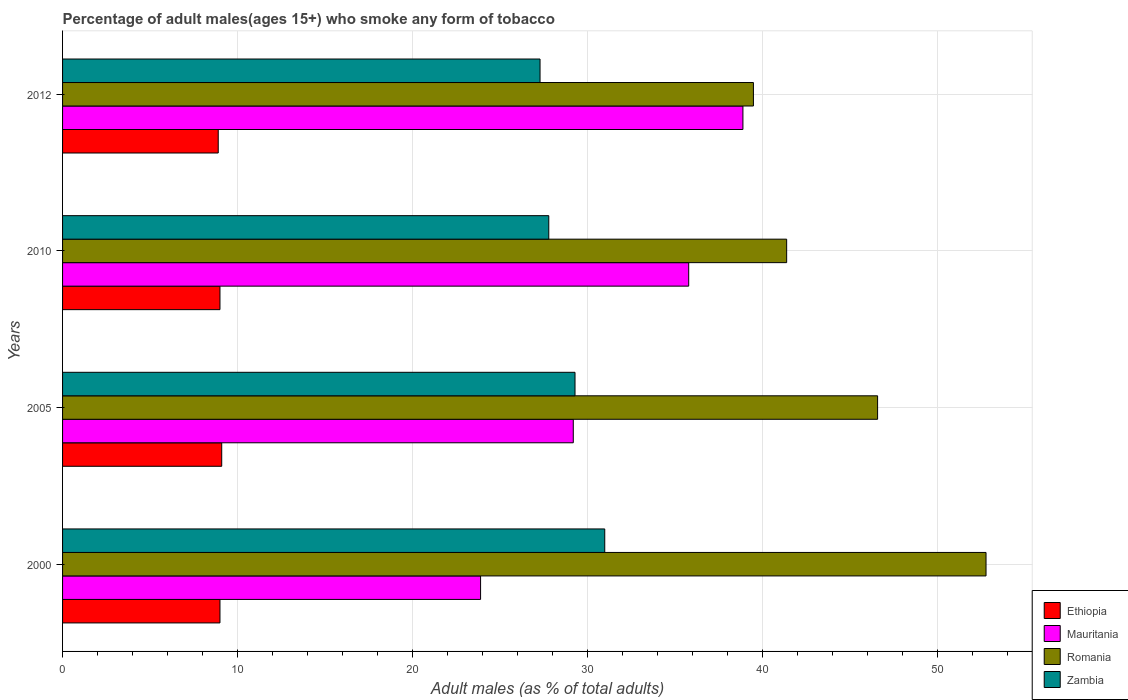Are the number of bars per tick equal to the number of legend labels?
Your answer should be compact. Yes. Are the number of bars on each tick of the Y-axis equal?
Your response must be concise. Yes. How many bars are there on the 2nd tick from the bottom?
Keep it short and to the point. 4. What is the label of the 4th group of bars from the top?
Offer a terse response. 2000. In how many cases, is the number of bars for a given year not equal to the number of legend labels?
Offer a terse response. 0. Across all years, what is the maximum percentage of adult males who smoke in Romania?
Keep it short and to the point. 52.8. Across all years, what is the minimum percentage of adult males who smoke in Romania?
Offer a very short reply. 39.5. In which year was the percentage of adult males who smoke in Romania maximum?
Offer a very short reply. 2000. What is the total percentage of adult males who smoke in Romania in the graph?
Offer a terse response. 180.3. What is the difference between the percentage of adult males who smoke in Ethiopia in 2000 and that in 2012?
Offer a very short reply. 0.1. What is the difference between the percentage of adult males who smoke in Zambia in 2000 and the percentage of adult males who smoke in Ethiopia in 2012?
Offer a terse response. 22.1. What is the average percentage of adult males who smoke in Mauritania per year?
Keep it short and to the point. 31.95. What is the ratio of the percentage of adult males who smoke in Zambia in 2000 to that in 2012?
Your response must be concise. 1.14. Is the percentage of adult males who smoke in Romania in 2005 less than that in 2012?
Your answer should be compact. No. Is the difference between the percentage of adult males who smoke in Zambia in 2000 and 2010 greater than the difference between the percentage of adult males who smoke in Ethiopia in 2000 and 2010?
Offer a very short reply. Yes. What is the difference between the highest and the second highest percentage of adult males who smoke in Mauritania?
Offer a terse response. 3.1. Is it the case that in every year, the sum of the percentage of adult males who smoke in Romania and percentage of adult males who smoke in Mauritania is greater than the sum of percentage of adult males who smoke in Ethiopia and percentage of adult males who smoke in Zambia?
Keep it short and to the point. Yes. What does the 1st bar from the top in 2010 represents?
Give a very brief answer. Zambia. What does the 1st bar from the bottom in 2012 represents?
Offer a very short reply. Ethiopia. How many bars are there?
Offer a very short reply. 16. Are all the bars in the graph horizontal?
Give a very brief answer. Yes. How many years are there in the graph?
Provide a succinct answer. 4. Are the values on the major ticks of X-axis written in scientific E-notation?
Your response must be concise. No. Does the graph contain any zero values?
Provide a succinct answer. No. Where does the legend appear in the graph?
Your answer should be very brief. Bottom right. How are the legend labels stacked?
Ensure brevity in your answer.  Vertical. What is the title of the graph?
Your answer should be compact. Percentage of adult males(ages 15+) who smoke any form of tobacco. What is the label or title of the X-axis?
Your answer should be very brief. Adult males (as % of total adults). What is the label or title of the Y-axis?
Keep it short and to the point. Years. What is the Adult males (as % of total adults) of Mauritania in 2000?
Give a very brief answer. 23.9. What is the Adult males (as % of total adults) of Romania in 2000?
Offer a terse response. 52.8. What is the Adult males (as % of total adults) in Zambia in 2000?
Give a very brief answer. 31. What is the Adult males (as % of total adults) of Mauritania in 2005?
Keep it short and to the point. 29.2. What is the Adult males (as % of total adults) in Romania in 2005?
Give a very brief answer. 46.6. What is the Adult males (as % of total adults) in Zambia in 2005?
Your response must be concise. 29.3. What is the Adult males (as % of total adults) of Mauritania in 2010?
Ensure brevity in your answer.  35.8. What is the Adult males (as % of total adults) of Romania in 2010?
Provide a succinct answer. 41.4. What is the Adult males (as % of total adults) in Zambia in 2010?
Offer a very short reply. 27.8. What is the Adult males (as % of total adults) in Mauritania in 2012?
Provide a succinct answer. 38.9. What is the Adult males (as % of total adults) of Romania in 2012?
Your response must be concise. 39.5. What is the Adult males (as % of total adults) of Zambia in 2012?
Keep it short and to the point. 27.3. Across all years, what is the maximum Adult males (as % of total adults) of Mauritania?
Provide a succinct answer. 38.9. Across all years, what is the maximum Adult males (as % of total adults) in Romania?
Your answer should be very brief. 52.8. Across all years, what is the minimum Adult males (as % of total adults) in Ethiopia?
Provide a succinct answer. 8.9. Across all years, what is the minimum Adult males (as % of total adults) in Mauritania?
Offer a very short reply. 23.9. Across all years, what is the minimum Adult males (as % of total adults) in Romania?
Your response must be concise. 39.5. Across all years, what is the minimum Adult males (as % of total adults) in Zambia?
Ensure brevity in your answer.  27.3. What is the total Adult males (as % of total adults) in Ethiopia in the graph?
Ensure brevity in your answer.  36. What is the total Adult males (as % of total adults) in Mauritania in the graph?
Provide a short and direct response. 127.8. What is the total Adult males (as % of total adults) of Romania in the graph?
Your answer should be very brief. 180.3. What is the total Adult males (as % of total adults) in Zambia in the graph?
Provide a succinct answer. 115.4. What is the difference between the Adult males (as % of total adults) in Mauritania in 2000 and that in 2005?
Ensure brevity in your answer.  -5.3. What is the difference between the Adult males (as % of total adults) in Zambia in 2000 and that in 2005?
Provide a short and direct response. 1.7. What is the difference between the Adult males (as % of total adults) of Zambia in 2000 and that in 2010?
Offer a terse response. 3.2. What is the difference between the Adult males (as % of total adults) in Ethiopia in 2000 and that in 2012?
Offer a very short reply. 0.1. What is the difference between the Adult males (as % of total adults) in Mauritania in 2000 and that in 2012?
Make the answer very short. -15. What is the difference between the Adult males (as % of total adults) in Mauritania in 2005 and that in 2010?
Offer a very short reply. -6.6. What is the difference between the Adult males (as % of total adults) in Zambia in 2005 and that in 2010?
Make the answer very short. 1.5. What is the difference between the Adult males (as % of total adults) of Ethiopia in 2005 and that in 2012?
Offer a terse response. 0.2. What is the difference between the Adult males (as % of total adults) of Zambia in 2005 and that in 2012?
Offer a very short reply. 2. What is the difference between the Adult males (as % of total adults) in Mauritania in 2010 and that in 2012?
Make the answer very short. -3.1. What is the difference between the Adult males (as % of total adults) of Ethiopia in 2000 and the Adult males (as % of total adults) of Mauritania in 2005?
Your response must be concise. -20.2. What is the difference between the Adult males (as % of total adults) in Ethiopia in 2000 and the Adult males (as % of total adults) in Romania in 2005?
Provide a succinct answer. -37.6. What is the difference between the Adult males (as % of total adults) of Ethiopia in 2000 and the Adult males (as % of total adults) of Zambia in 2005?
Give a very brief answer. -20.3. What is the difference between the Adult males (as % of total adults) of Mauritania in 2000 and the Adult males (as % of total adults) of Romania in 2005?
Your response must be concise. -22.7. What is the difference between the Adult males (as % of total adults) of Ethiopia in 2000 and the Adult males (as % of total adults) of Mauritania in 2010?
Ensure brevity in your answer.  -26.8. What is the difference between the Adult males (as % of total adults) in Ethiopia in 2000 and the Adult males (as % of total adults) in Romania in 2010?
Offer a very short reply. -32.4. What is the difference between the Adult males (as % of total adults) of Ethiopia in 2000 and the Adult males (as % of total adults) of Zambia in 2010?
Your answer should be compact. -18.8. What is the difference between the Adult males (as % of total adults) of Mauritania in 2000 and the Adult males (as % of total adults) of Romania in 2010?
Your answer should be very brief. -17.5. What is the difference between the Adult males (as % of total adults) of Romania in 2000 and the Adult males (as % of total adults) of Zambia in 2010?
Your answer should be very brief. 25. What is the difference between the Adult males (as % of total adults) of Ethiopia in 2000 and the Adult males (as % of total adults) of Mauritania in 2012?
Give a very brief answer. -29.9. What is the difference between the Adult males (as % of total adults) in Ethiopia in 2000 and the Adult males (as % of total adults) in Romania in 2012?
Offer a very short reply. -30.5. What is the difference between the Adult males (as % of total adults) of Ethiopia in 2000 and the Adult males (as % of total adults) of Zambia in 2012?
Give a very brief answer. -18.3. What is the difference between the Adult males (as % of total adults) in Mauritania in 2000 and the Adult males (as % of total adults) in Romania in 2012?
Offer a very short reply. -15.6. What is the difference between the Adult males (as % of total adults) of Ethiopia in 2005 and the Adult males (as % of total adults) of Mauritania in 2010?
Keep it short and to the point. -26.7. What is the difference between the Adult males (as % of total adults) of Ethiopia in 2005 and the Adult males (as % of total adults) of Romania in 2010?
Make the answer very short. -32.3. What is the difference between the Adult males (as % of total adults) in Ethiopia in 2005 and the Adult males (as % of total adults) in Zambia in 2010?
Offer a terse response. -18.7. What is the difference between the Adult males (as % of total adults) in Mauritania in 2005 and the Adult males (as % of total adults) in Romania in 2010?
Provide a short and direct response. -12.2. What is the difference between the Adult males (as % of total adults) of Romania in 2005 and the Adult males (as % of total adults) of Zambia in 2010?
Keep it short and to the point. 18.8. What is the difference between the Adult males (as % of total adults) in Ethiopia in 2005 and the Adult males (as % of total adults) in Mauritania in 2012?
Your response must be concise. -29.8. What is the difference between the Adult males (as % of total adults) of Ethiopia in 2005 and the Adult males (as % of total adults) of Romania in 2012?
Your response must be concise. -30.4. What is the difference between the Adult males (as % of total adults) in Ethiopia in 2005 and the Adult males (as % of total adults) in Zambia in 2012?
Give a very brief answer. -18.2. What is the difference between the Adult males (as % of total adults) of Romania in 2005 and the Adult males (as % of total adults) of Zambia in 2012?
Make the answer very short. 19.3. What is the difference between the Adult males (as % of total adults) in Ethiopia in 2010 and the Adult males (as % of total adults) in Mauritania in 2012?
Offer a very short reply. -29.9. What is the difference between the Adult males (as % of total adults) of Ethiopia in 2010 and the Adult males (as % of total adults) of Romania in 2012?
Provide a short and direct response. -30.5. What is the difference between the Adult males (as % of total adults) of Ethiopia in 2010 and the Adult males (as % of total adults) of Zambia in 2012?
Keep it short and to the point. -18.3. What is the difference between the Adult males (as % of total adults) in Mauritania in 2010 and the Adult males (as % of total adults) in Romania in 2012?
Your answer should be very brief. -3.7. What is the average Adult males (as % of total adults) of Ethiopia per year?
Provide a short and direct response. 9. What is the average Adult males (as % of total adults) of Mauritania per year?
Your answer should be compact. 31.95. What is the average Adult males (as % of total adults) in Romania per year?
Ensure brevity in your answer.  45.08. What is the average Adult males (as % of total adults) in Zambia per year?
Give a very brief answer. 28.85. In the year 2000, what is the difference between the Adult males (as % of total adults) in Ethiopia and Adult males (as % of total adults) in Mauritania?
Provide a succinct answer. -14.9. In the year 2000, what is the difference between the Adult males (as % of total adults) in Ethiopia and Adult males (as % of total adults) in Romania?
Your response must be concise. -43.8. In the year 2000, what is the difference between the Adult males (as % of total adults) in Ethiopia and Adult males (as % of total adults) in Zambia?
Provide a succinct answer. -22. In the year 2000, what is the difference between the Adult males (as % of total adults) in Mauritania and Adult males (as % of total adults) in Romania?
Keep it short and to the point. -28.9. In the year 2000, what is the difference between the Adult males (as % of total adults) in Mauritania and Adult males (as % of total adults) in Zambia?
Make the answer very short. -7.1. In the year 2000, what is the difference between the Adult males (as % of total adults) in Romania and Adult males (as % of total adults) in Zambia?
Your answer should be very brief. 21.8. In the year 2005, what is the difference between the Adult males (as % of total adults) in Ethiopia and Adult males (as % of total adults) in Mauritania?
Provide a succinct answer. -20.1. In the year 2005, what is the difference between the Adult males (as % of total adults) in Ethiopia and Adult males (as % of total adults) in Romania?
Make the answer very short. -37.5. In the year 2005, what is the difference between the Adult males (as % of total adults) of Ethiopia and Adult males (as % of total adults) of Zambia?
Your answer should be compact. -20.2. In the year 2005, what is the difference between the Adult males (as % of total adults) of Mauritania and Adult males (as % of total adults) of Romania?
Make the answer very short. -17.4. In the year 2005, what is the difference between the Adult males (as % of total adults) in Romania and Adult males (as % of total adults) in Zambia?
Your answer should be very brief. 17.3. In the year 2010, what is the difference between the Adult males (as % of total adults) in Ethiopia and Adult males (as % of total adults) in Mauritania?
Offer a very short reply. -26.8. In the year 2010, what is the difference between the Adult males (as % of total adults) of Ethiopia and Adult males (as % of total adults) of Romania?
Give a very brief answer. -32.4. In the year 2010, what is the difference between the Adult males (as % of total adults) of Ethiopia and Adult males (as % of total adults) of Zambia?
Provide a succinct answer. -18.8. In the year 2010, what is the difference between the Adult males (as % of total adults) in Mauritania and Adult males (as % of total adults) in Romania?
Keep it short and to the point. -5.6. In the year 2010, what is the difference between the Adult males (as % of total adults) in Romania and Adult males (as % of total adults) in Zambia?
Keep it short and to the point. 13.6. In the year 2012, what is the difference between the Adult males (as % of total adults) of Ethiopia and Adult males (as % of total adults) of Mauritania?
Offer a terse response. -30. In the year 2012, what is the difference between the Adult males (as % of total adults) of Ethiopia and Adult males (as % of total adults) of Romania?
Ensure brevity in your answer.  -30.6. In the year 2012, what is the difference between the Adult males (as % of total adults) in Ethiopia and Adult males (as % of total adults) in Zambia?
Ensure brevity in your answer.  -18.4. In the year 2012, what is the difference between the Adult males (as % of total adults) in Mauritania and Adult males (as % of total adults) in Romania?
Your response must be concise. -0.6. In the year 2012, what is the difference between the Adult males (as % of total adults) of Mauritania and Adult males (as % of total adults) of Zambia?
Offer a very short reply. 11.6. What is the ratio of the Adult males (as % of total adults) in Ethiopia in 2000 to that in 2005?
Make the answer very short. 0.99. What is the ratio of the Adult males (as % of total adults) in Mauritania in 2000 to that in 2005?
Keep it short and to the point. 0.82. What is the ratio of the Adult males (as % of total adults) of Romania in 2000 to that in 2005?
Ensure brevity in your answer.  1.13. What is the ratio of the Adult males (as % of total adults) in Zambia in 2000 to that in 2005?
Your answer should be compact. 1.06. What is the ratio of the Adult males (as % of total adults) in Ethiopia in 2000 to that in 2010?
Offer a very short reply. 1. What is the ratio of the Adult males (as % of total adults) of Mauritania in 2000 to that in 2010?
Provide a short and direct response. 0.67. What is the ratio of the Adult males (as % of total adults) of Romania in 2000 to that in 2010?
Provide a short and direct response. 1.28. What is the ratio of the Adult males (as % of total adults) in Zambia in 2000 to that in 2010?
Provide a succinct answer. 1.12. What is the ratio of the Adult males (as % of total adults) of Ethiopia in 2000 to that in 2012?
Ensure brevity in your answer.  1.01. What is the ratio of the Adult males (as % of total adults) of Mauritania in 2000 to that in 2012?
Ensure brevity in your answer.  0.61. What is the ratio of the Adult males (as % of total adults) in Romania in 2000 to that in 2012?
Keep it short and to the point. 1.34. What is the ratio of the Adult males (as % of total adults) in Zambia in 2000 to that in 2012?
Ensure brevity in your answer.  1.14. What is the ratio of the Adult males (as % of total adults) of Ethiopia in 2005 to that in 2010?
Your response must be concise. 1.01. What is the ratio of the Adult males (as % of total adults) of Mauritania in 2005 to that in 2010?
Ensure brevity in your answer.  0.82. What is the ratio of the Adult males (as % of total adults) in Romania in 2005 to that in 2010?
Ensure brevity in your answer.  1.13. What is the ratio of the Adult males (as % of total adults) in Zambia in 2005 to that in 2010?
Give a very brief answer. 1.05. What is the ratio of the Adult males (as % of total adults) of Ethiopia in 2005 to that in 2012?
Your answer should be compact. 1.02. What is the ratio of the Adult males (as % of total adults) in Mauritania in 2005 to that in 2012?
Provide a short and direct response. 0.75. What is the ratio of the Adult males (as % of total adults) of Romania in 2005 to that in 2012?
Keep it short and to the point. 1.18. What is the ratio of the Adult males (as % of total adults) of Zambia in 2005 to that in 2012?
Provide a short and direct response. 1.07. What is the ratio of the Adult males (as % of total adults) of Ethiopia in 2010 to that in 2012?
Your answer should be very brief. 1.01. What is the ratio of the Adult males (as % of total adults) in Mauritania in 2010 to that in 2012?
Keep it short and to the point. 0.92. What is the ratio of the Adult males (as % of total adults) in Romania in 2010 to that in 2012?
Your answer should be very brief. 1.05. What is the ratio of the Adult males (as % of total adults) in Zambia in 2010 to that in 2012?
Keep it short and to the point. 1.02. What is the difference between the highest and the second highest Adult males (as % of total adults) of Ethiopia?
Keep it short and to the point. 0.1. What is the difference between the highest and the second highest Adult males (as % of total adults) in Mauritania?
Offer a very short reply. 3.1. What is the difference between the highest and the lowest Adult males (as % of total adults) in Mauritania?
Make the answer very short. 15. 